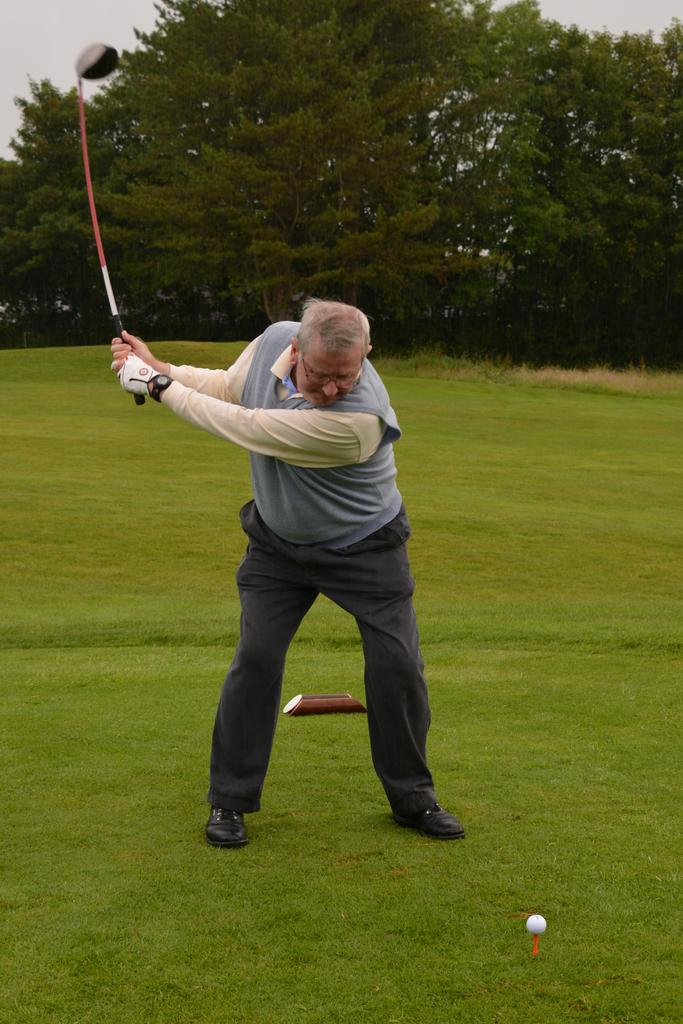What is the man in the image doing? The man is standing in the image and holding a stick. What object is visible in the image that might be related to the man's activity? There is a ball visible in the image. What is located on the grass in the image? There is an object on the grass, but the specific object is not mentioned in the facts. What can be seen in the background of the image? There are trees and the sky visible in the background of the image. How many lizards are visible in the image? There are no lizards present in the image. What type of battle is taking place in the image? There is no battle depicted in the image. 